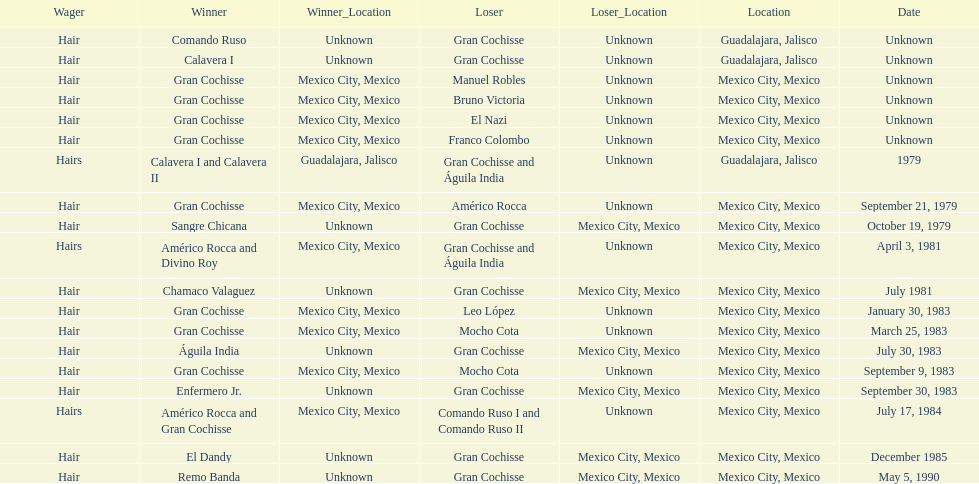What was the number of losses gran cochisse had against el dandy? 1. 